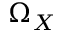Convert formula to latex. <formula><loc_0><loc_0><loc_500><loc_500>\Omega _ { X }</formula> 